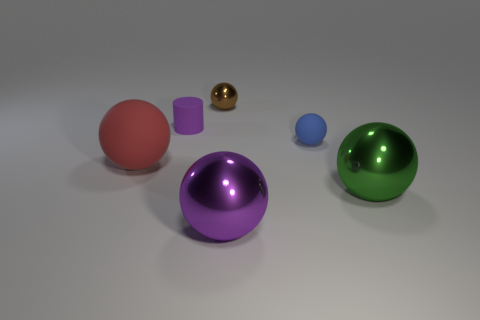Subtract all green metallic balls. How many balls are left? 4 Subtract all blue spheres. How many spheres are left? 4 Subtract all cyan spheres. Subtract all yellow cylinders. How many spheres are left? 5 Add 2 large rubber spheres. How many objects exist? 8 Subtract all cylinders. How many objects are left? 5 Subtract 1 brown spheres. How many objects are left? 5 Subtract all big red rubber balls. Subtract all purple shiny things. How many objects are left? 4 Add 6 metal objects. How many metal objects are left? 9 Add 4 tiny purple cylinders. How many tiny purple cylinders exist? 5 